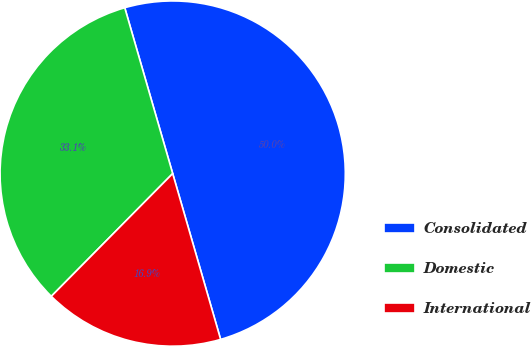<chart> <loc_0><loc_0><loc_500><loc_500><pie_chart><fcel>Consolidated<fcel>Domestic<fcel>International<nl><fcel>50.0%<fcel>33.11%<fcel>16.89%<nl></chart> 